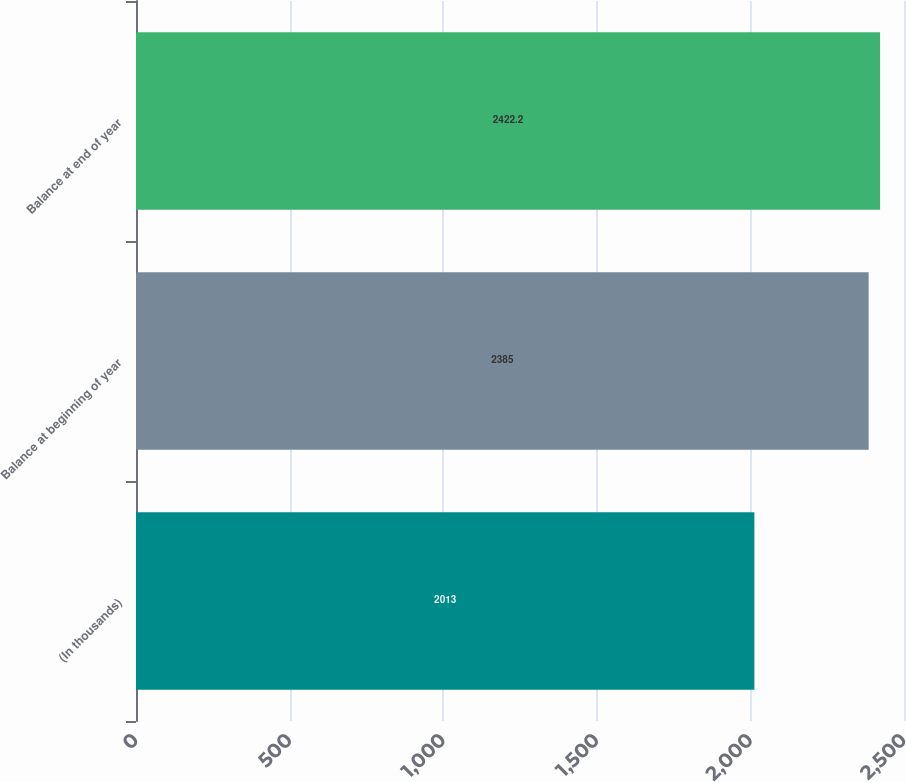Convert chart. <chart><loc_0><loc_0><loc_500><loc_500><bar_chart><fcel>(In thousands)<fcel>Balance at beginning of year<fcel>Balance at end of year<nl><fcel>2013<fcel>2385<fcel>2422.2<nl></chart> 